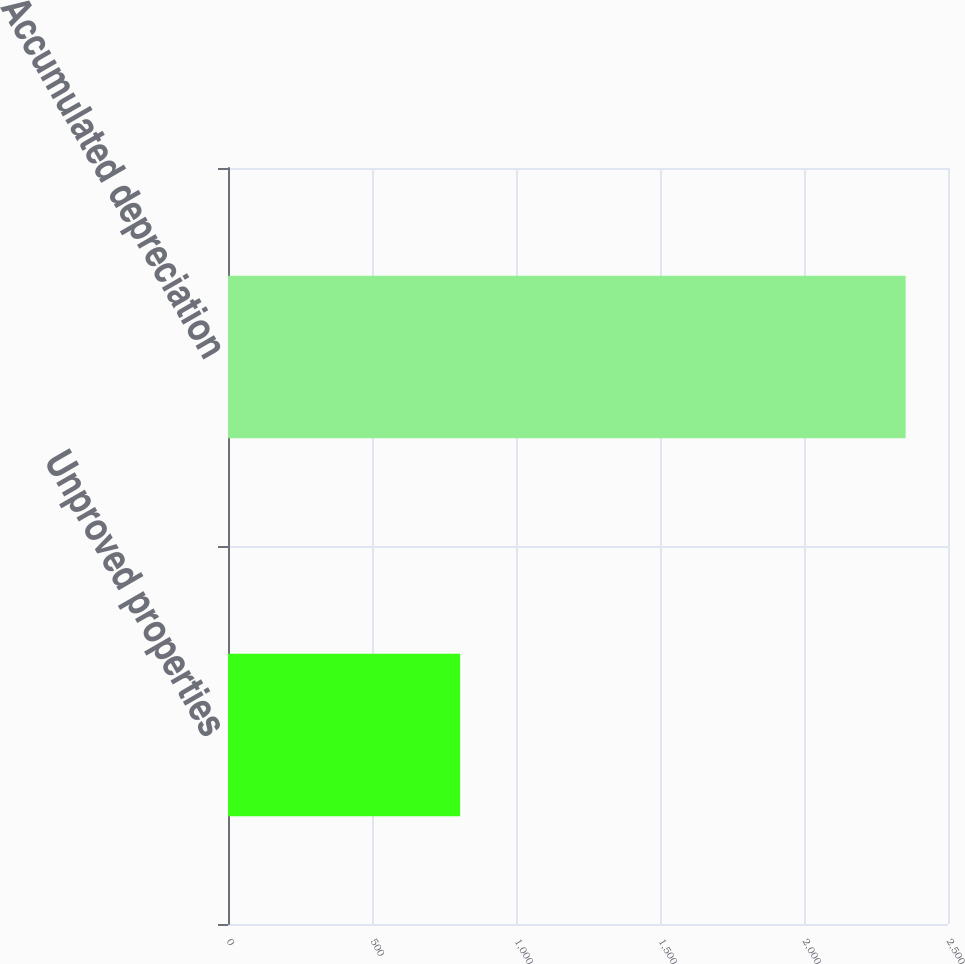Convert chart to OTSL. <chart><loc_0><loc_0><loc_500><loc_500><bar_chart><fcel>Unproved properties<fcel>Accumulated depreciation<nl><fcel>806<fcel>2353<nl></chart> 